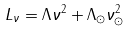<formula> <loc_0><loc_0><loc_500><loc_500>L _ { \nu } = \Lambda \nu ^ { 2 } + \Lambda _ { \odot } \nu _ { \odot } ^ { 2 }</formula> 